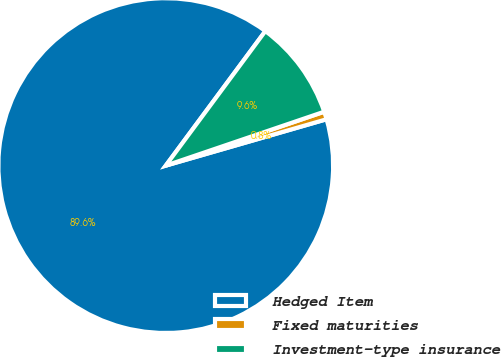Convert chart. <chart><loc_0><loc_0><loc_500><loc_500><pie_chart><fcel>Hedged Item<fcel>Fixed maturities<fcel>Investment-type insurance<nl><fcel>89.61%<fcel>0.75%<fcel>9.64%<nl></chart> 